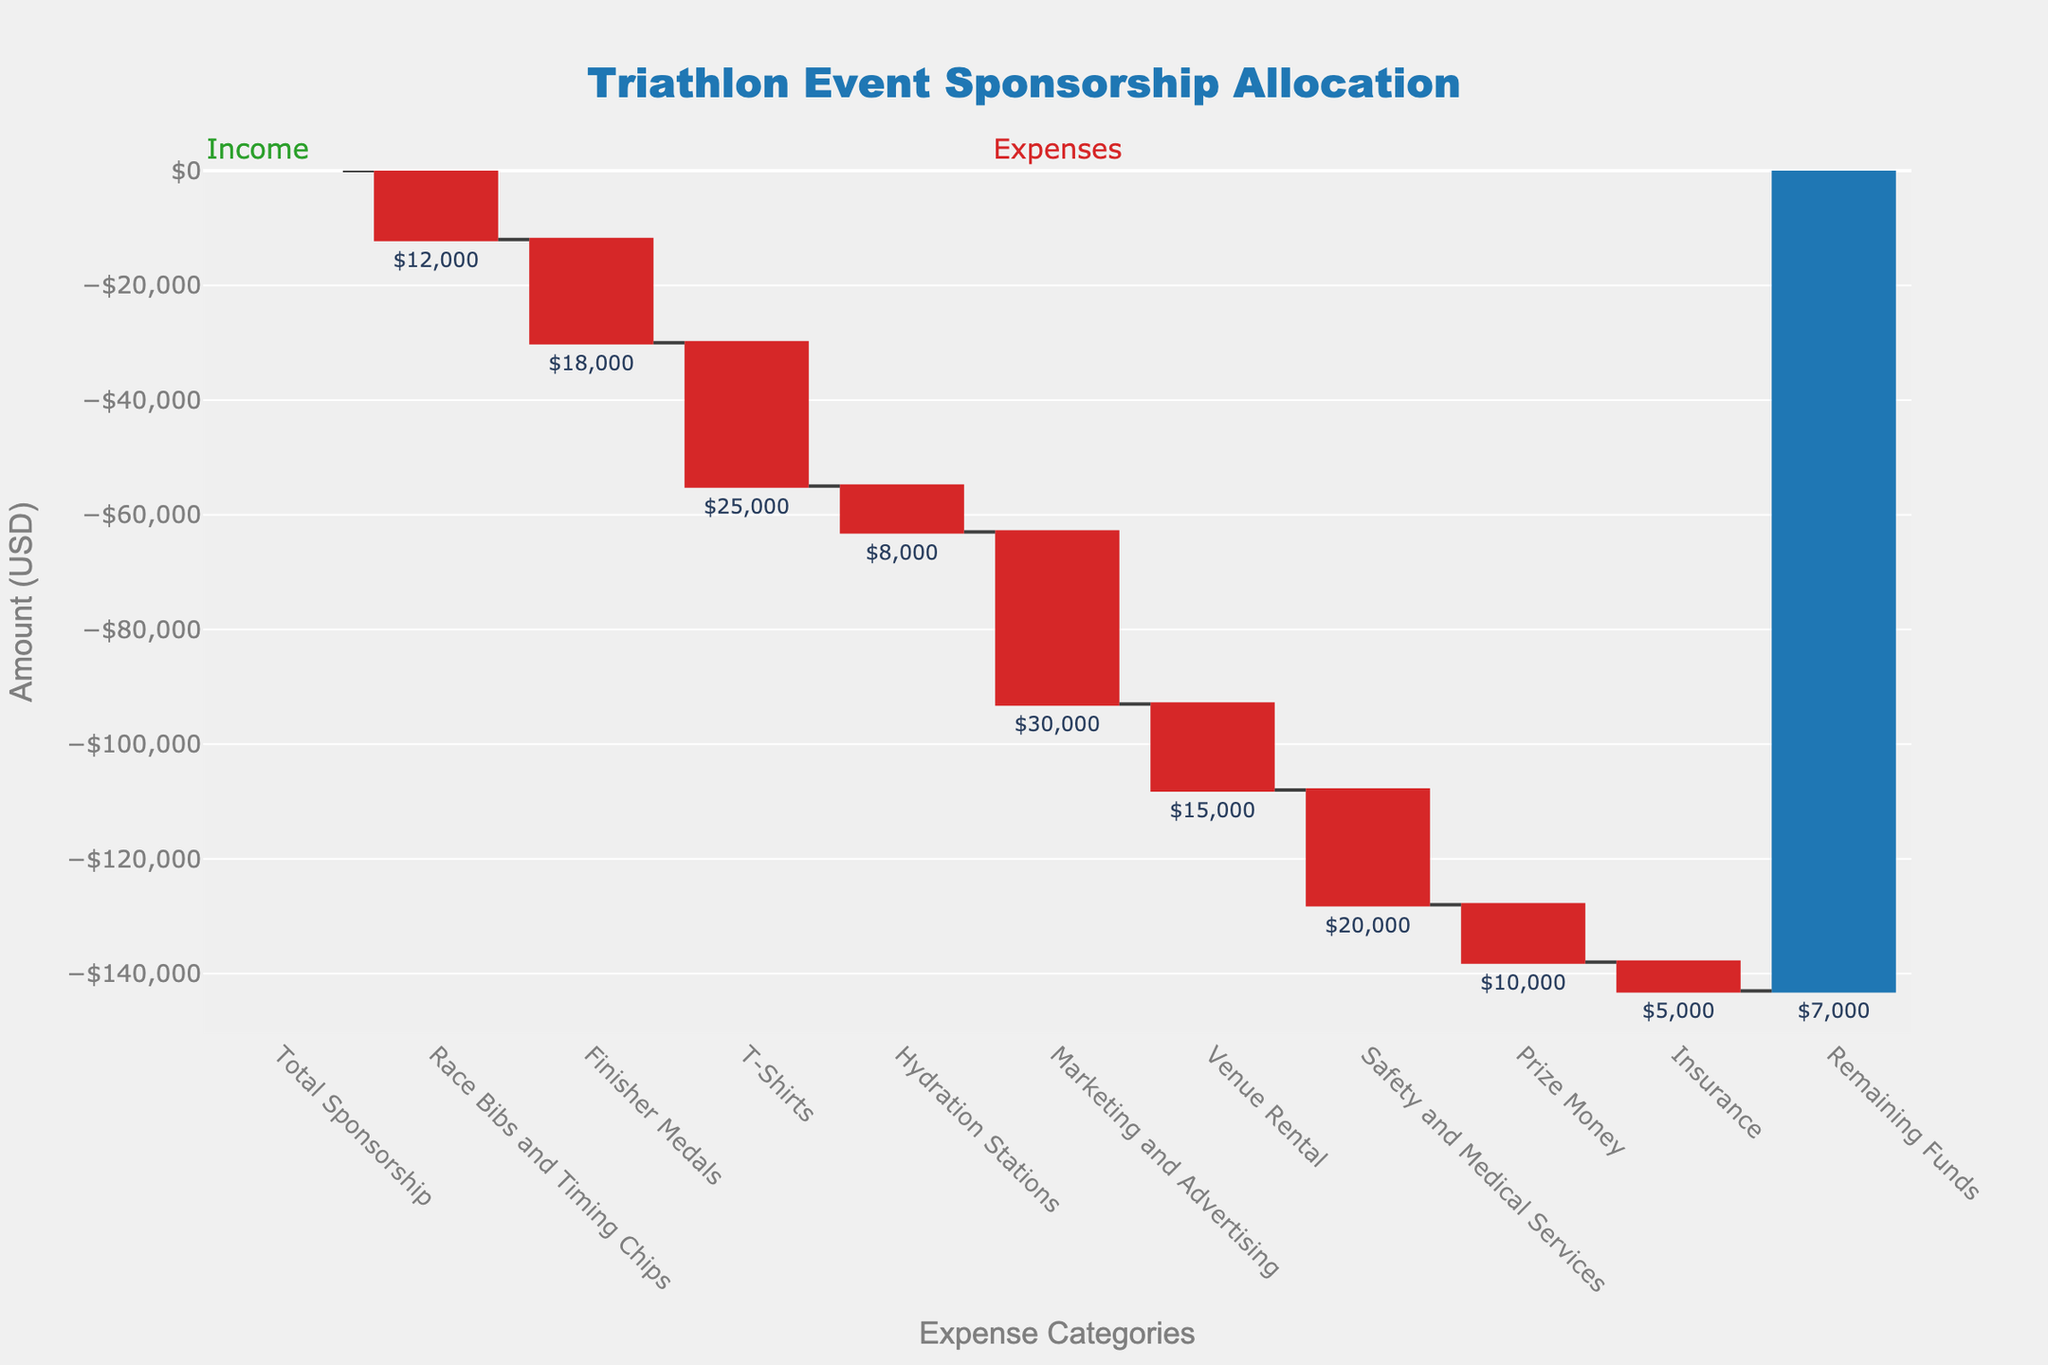What's the title of the figure? The figure has a title at the top, centered and in bold font. It reads "Triathlon Event Sponsorship Allocation".
Answer: Triathlon Event Sponsorship Allocation What is the total amount of sponsorship received for the event? The total sponsorship received is shown as the first bar on the left of the figure in green with its label as $150,000.
Answer: $150,000 What is the amount allocated for Marketing and Advertising? The allocated amount for Marketing and Advertising is shown as a red bar labeled -$30,000.
Answer: $30,000 How much is left after covering all expenses? The final bar in blue labeled Remaining Funds shows $7,000.
Answer: $7,000 Is the cost of Insurance higher or lower than that of Hydration Stations? Compare the red bars for these two categories: Insurance is -$5,000 and Hydration Stations is -$8,000. The cost of Insurance is lower.
Answer: lower What is the total amount spent on Safety and Medical Services and Prize Money? Add the values for Safety and Medical Services (-$20,000) and Prize Money (-$10,000). The total is -$20,000 + -$10,000 = -$30,000.
Answer: $30,000 How many categories have expenses exceeding $20,000? Finisher Medals, T-Shirts, and Marketing and Advertising each have a red bar with an amount greater than $20,000, totaling three categories.
Answer: three Which expense category has the highest allocation? Among the red bars, Marketing and Advertising has the highest value with -$30,000.
Answer: Marketing and Advertising What’s the total value of all expenses combined? Sum all the expense values: -$12,000 + -$18,000 + -$25,000 + -$8,000 + -$30,000 + -$15,000 + -$20,000 + -$10,000 + -$5,000 = -$143,000.
Answer: $143,000 What is the average cost across all expense categories? The total expense amount is -$143,000, divide this by the number of categories (9). Average = -$143,000 / 9 ≈ -$15,889.
Answer: $15,889 